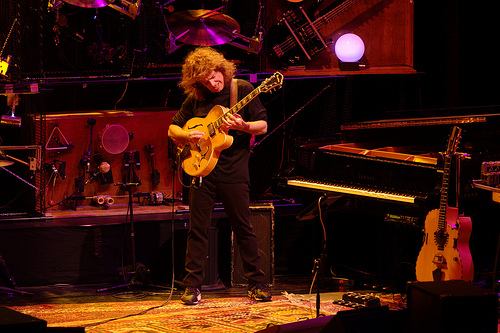<image>
Is there a cymbal behind the man? Yes. From this viewpoint, the cymbal is positioned behind the man, with the man partially or fully occluding the cymbal. 